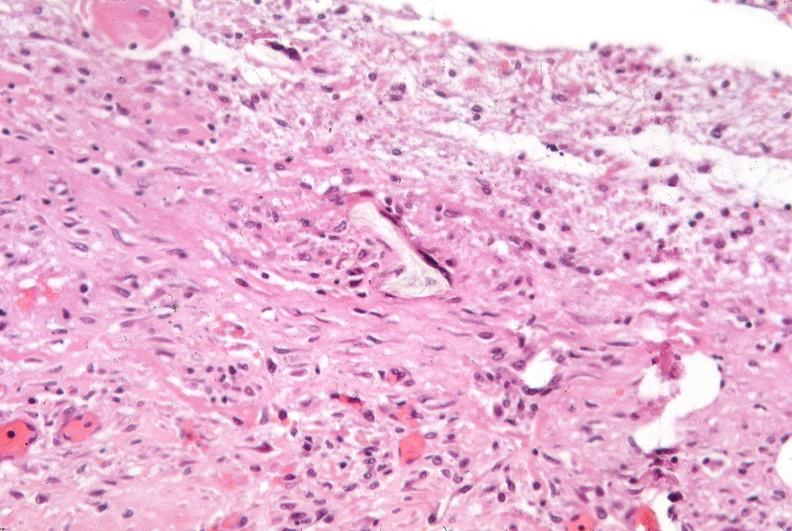what was talc used, alpha-1 antitrypsin deficiency?
Answer the question using a single word or phrase. Used to sclerose emphysematous lung 